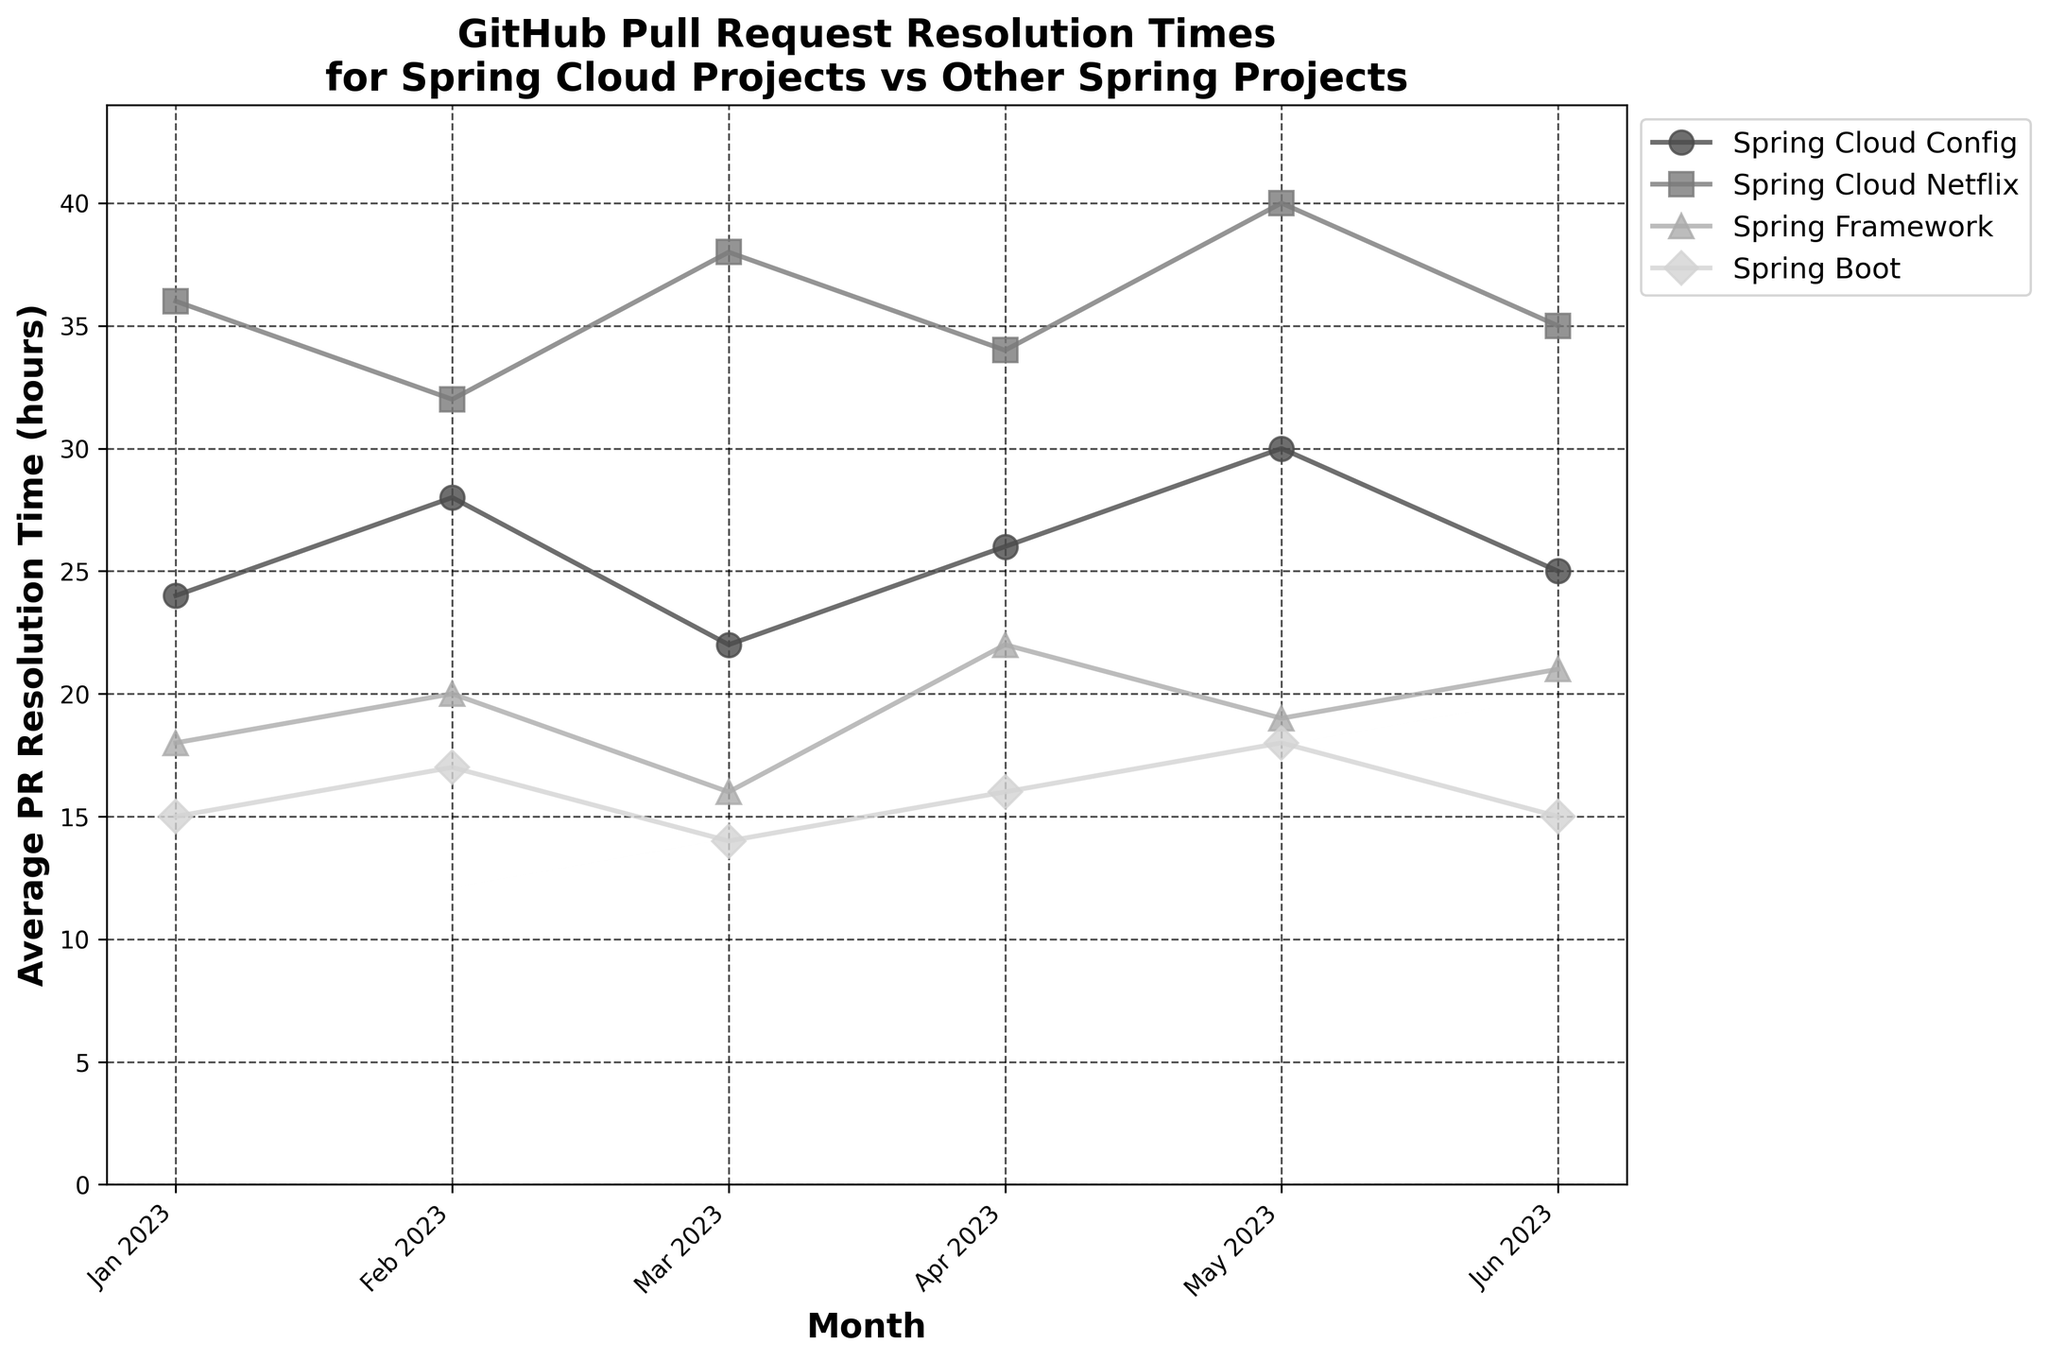Which project has the highest average PR resolution time in May 2023? Look for May 2023 data points and compare the average PR resolution times for all projects. The highest value is for Spring Cloud Netflix with 40 hours.
Answer: Spring Cloud Netflix Which month had the lowest average PR resolution time for Spring Boot? Check the data points for Spring Boot over all months and identify the lowest value. The lowest number is 14 hours in March 2023.
Answer: March 2023 What is the difference in average PR resolution times between Spring Cloud Config and Spring Framework in February 2023? Subtract the average PR resolution time of Spring Framework in February 2023 (20 hours) from that of Spring Cloud Config (28 hours). The difference is 8 hours.
Answer: 8 hours Which project generally has the most consistent average PR resolution time based on the figure? Observe the fluctuation of average PR resolution times for each project over the months. The project with the least fluctuation is Spring Boot, as the values range between 14 and 18 hours.
Answer: Spring Boot How many months did Spring Cloud Netflix have an average PR resolution time greater than 35 hours? Look at each month for Spring Cloud Netflix and count the months with a PR resolution time over 35 hours. The months are March and May, totaling 2 months.
Answer: 2 months Which project showed the most improvement in average PR resolution time from February 2023 to March 2023? Compare the reduction in PR resolution time from February to March for each project. Spring Cloud Config improved by 6 hours (28 - 22), which is the highest improvement among all projects.
Answer: Spring Cloud Config What is the average PR resolution time for Spring Cloud Config for the first half of 2023? Add the values for January to June for Spring Cloud Config and divide by 6: (24 + 28 + 22 + 26 + 30 + 25) / 6 = 25 hours.
Answer: 25 hours Which project had the largest fluctuation in average PR resolution time between any two consecutive months? Look at the changes in PR resolution time between consecutive months for each project. Spring Cloud Netflix had the largest fluctuation between February and March from 32 to 38 hours, a change of 6 hours.
Answer: Spring Cloud Netflix 